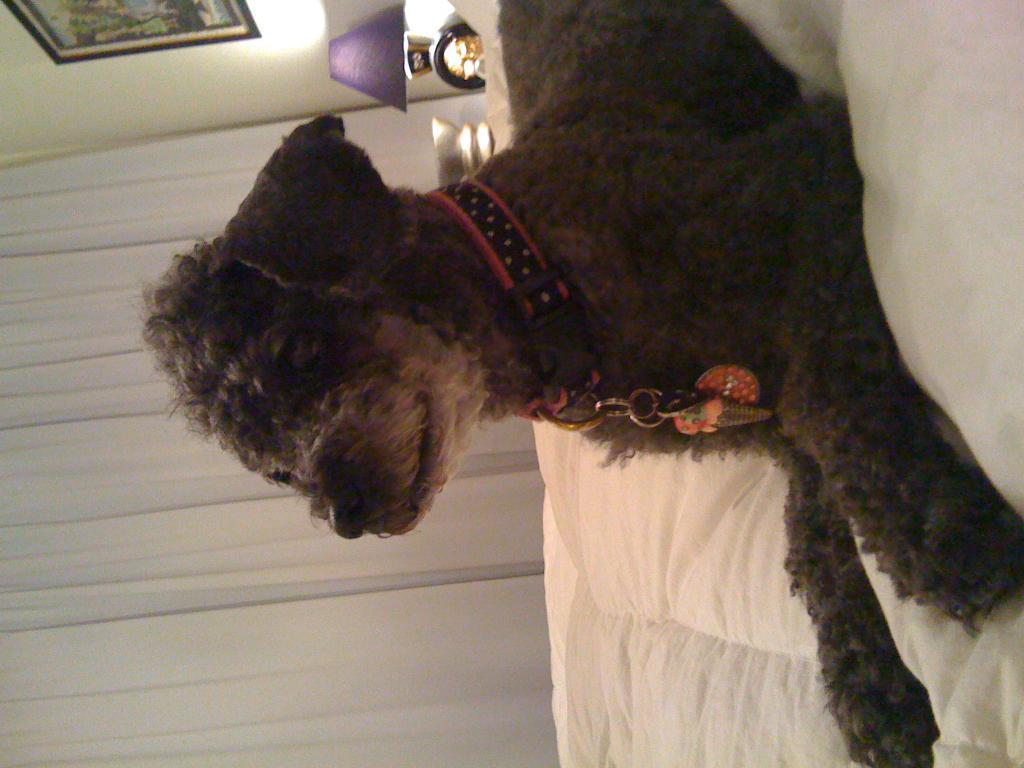Please provide a concise description of this image. In this rotated image there is a dog sitting on the bed. There is a belt around its neck. To the left there is a curtain to the wall. At the top there is a table lamp on the table. There is a picture frame on the wall. 